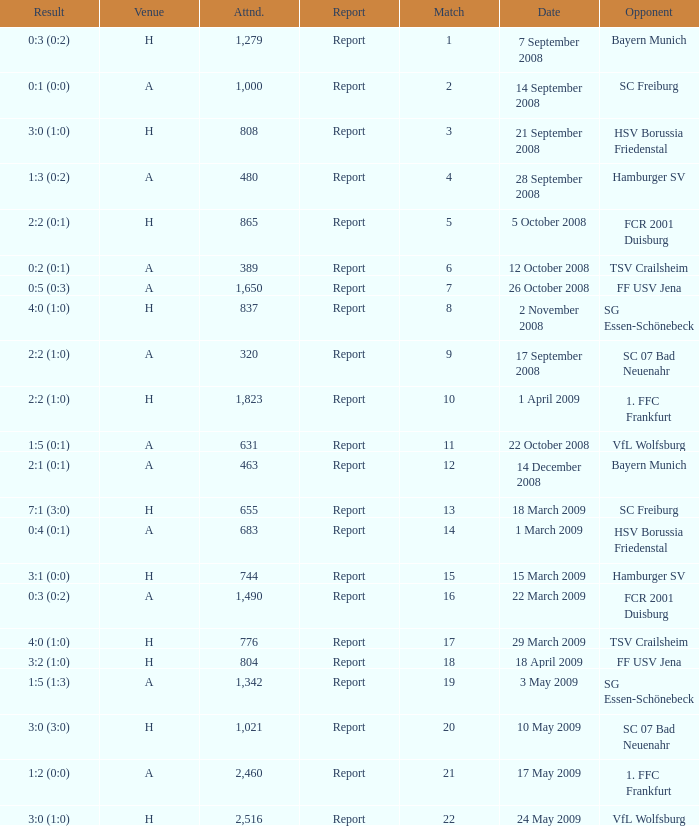Can you parse all the data within this table? {'header': ['Result', 'Venue', 'Attnd.', 'Report', 'Match', 'Date', 'Opponent'], 'rows': [['0:3 (0:2)', 'H', '1,279', 'Report', '1', '7 September 2008', 'Bayern Munich'], ['0:1 (0:0)', 'A', '1,000', 'Report', '2', '14 September 2008', 'SC Freiburg'], ['3:0 (1:0)', 'H', '808', 'Report', '3', '21 September 2008', 'HSV Borussia Friedenstal'], ['1:3 (0:2)', 'A', '480', 'Report', '4', '28 September 2008', 'Hamburger SV'], ['2:2 (0:1)', 'H', '865', 'Report', '5', '5 October 2008', 'FCR 2001 Duisburg'], ['0:2 (0:1)', 'A', '389', 'Report', '6', '12 October 2008', 'TSV Crailsheim'], ['0:5 (0:3)', 'A', '1,650', 'Report', '7', '26 October 2008', 'FF USV Jena'], ['4:0 (1:0)', 'H', '837', 'Report', '8', '2 November 2008', 'SG Essen-Schönebeck'], ['2:2 (1:0)', 'A', '320', 'Report', '9', '17 September 2008', 'SC 07 Bad Neuenahr'], ['2:2 (1:0)', 'H', '1,823', 'Report', '10', '1 April 2009', '1. FFC Frankfurt'], ['1:5 (0:1)', 'A', '631', 'Report', '11', '22 October 2008', 'VfL Wolfsburg'], ['2:1 (0:1)', 'A', '463', 'Report', '12', '14 December 2008', 'Bayern Munich'], ['7:1 (3:0)', 'H', '655', 'Report', '13', '18 March 2009', 'SC Freiburg'], ['0:4 (0:1)', 'A', '683', 'Report', '14', '1 March 2009', 'HSV Borussia Friedenstal'], ['3:1 (0:0)', 'H', '744', 'Report', '15', '15 March 2009', 'Hamburger SV'], ['0:3 (0:2)', 'A', '1,490', 'Report', '16', '22 March 2009', 'FCR 2001 Duisburg'], ['4:0 (1:0)', 'H', '776', 'Report', '17', '29 March 2009', 'TSV Crailsheim'], ['3:2 (1:0)', 'H', '804', 'Report', '18', '18 April 2009', 'FF USV Jena'], ['1:5 (1:3)', 'A', '1,342', 'Report', '19', '3 May 2009', 'SG Essen-Schönebeck'], ['3:0 (3:0)', 'H', '1,021', 'Report', '20', '10 May 2009', 'SC 07 Bad Neuenahr'], ['1:2 (0:0)', 'A', '2,460', 'Report', '21', '17 May 2009', '1. FFC Frankfurt'], ['3:0 (1:0)', 'H', '2,516', 'Report', '22', '24 May 2009', 'VfL Wolfsburg']]} What is the match number that had a result of 0:5 (0:3)? 1.0. 